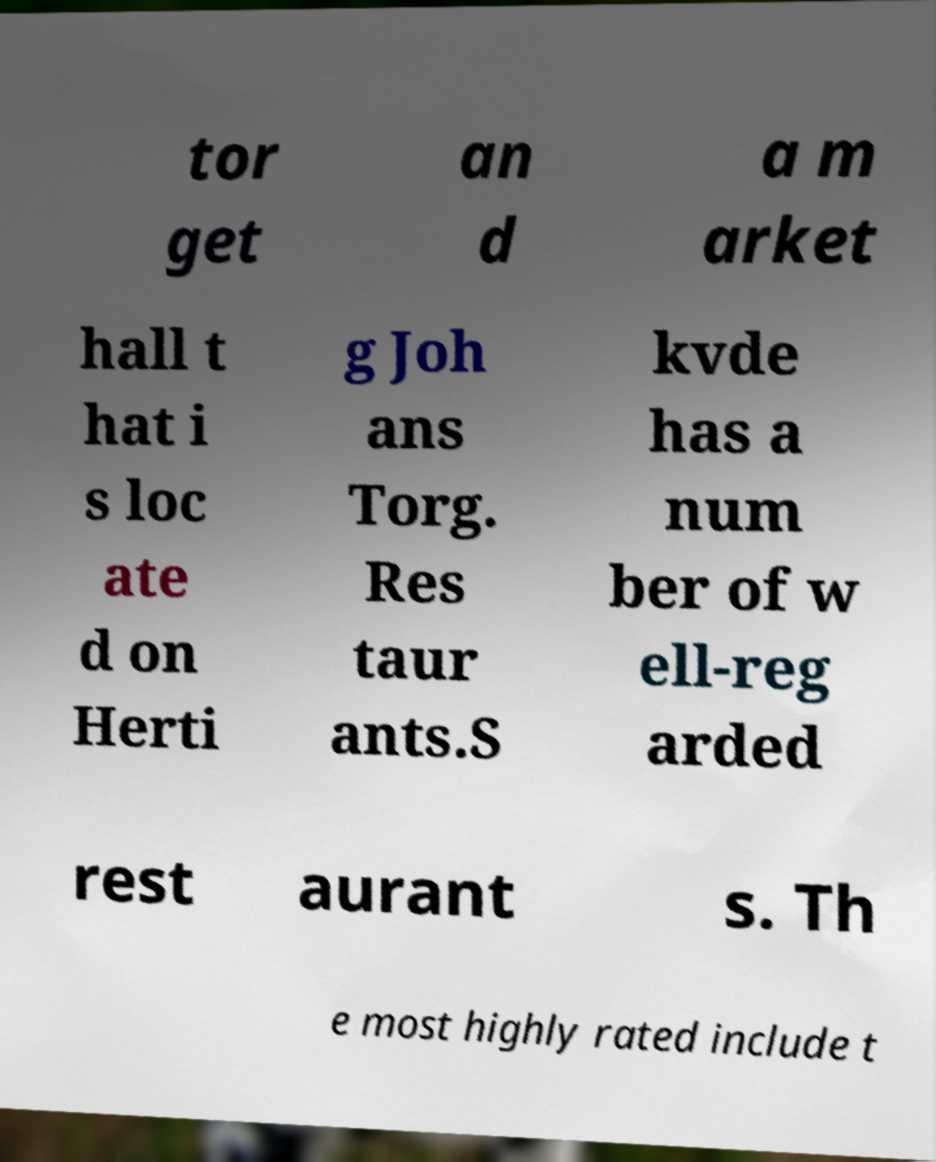Please read and relay the text visible in this image. What does it say? tor get an d a m arket hall t hat i s loc ate d on Herti g Joh ans Torg. Res taur ants.S kvde has a num ber of w ell-reg arded rest aurant s. Th e most highly rated include t 